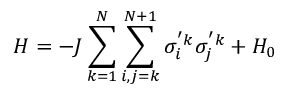<formula> <loc_0><loc_0><loc_500><loc_500>H = - J \sum _ { k = 1 } ^ { N } { \sum _ { i , j = k } ^ { N + 1 } { \sigma _ { i } ^ { ^ { \prime } k } \sigma _ { j } ^ { ^ { \prime } k } } } + { H _ { 0 } }</formula> 